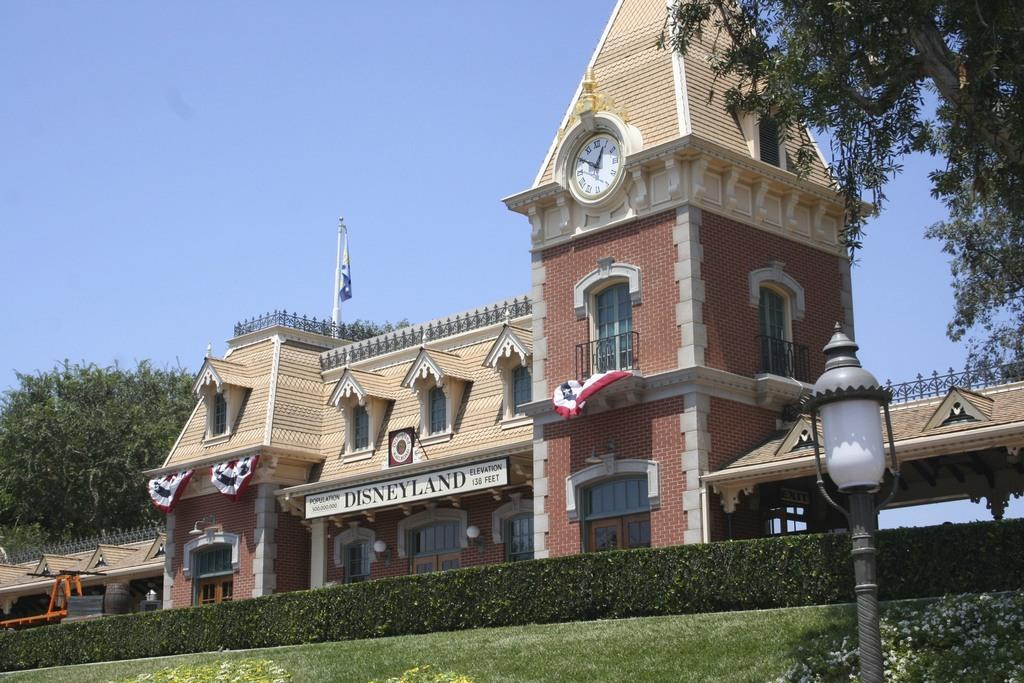<image>
Provide a brief description of the given image. The brick building is named Disneyland with a clock 